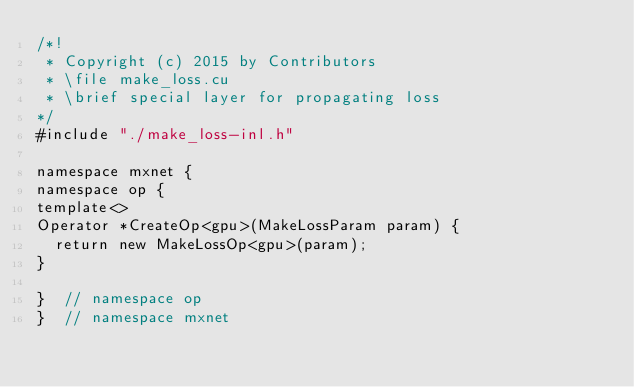Convert code to text. <code><loc_0><loc_0><loc_500><loc_500><_Cuda_>/*!
 * Copyright (c) 2015 by Contributors
 * \file make_loss.cu
 * \brief special layer for propagating loss
*/
#include "./make_loss-inl.h"

namespace mxnet {
namespace op {
template<>
Operator *CreateOp<gpu>(MakeLossParam param) {
  return new MakeLossOp<gpu>(param);
}

}  // namespace op
}  // namespace mxnet

</code> 